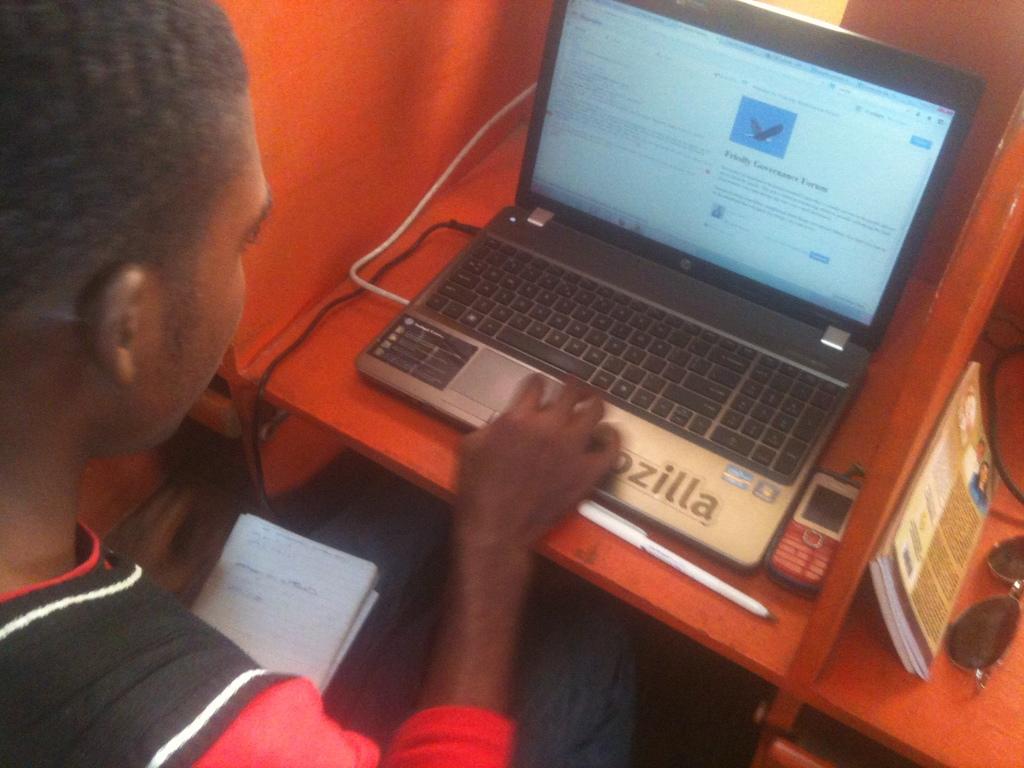What is written in big letters next to his hand?
Give a very brief answer. Ozilla. 